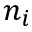Convert formula to latex. <formula><loc_0><loc_0><loc_500><loc_500>n _ { i }</formula> 